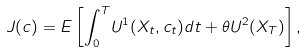<formula> <loc_0><loc_0><loc_500><loc_500>J ( c ) = E \left [ { \int _ { 0 } ^ { T } } U ^ { 1 } ( X _ { t } , c _ { t } ) d t + \theta U ^ { 2 } ( X _ { T } ) \right ] ,</formula> 